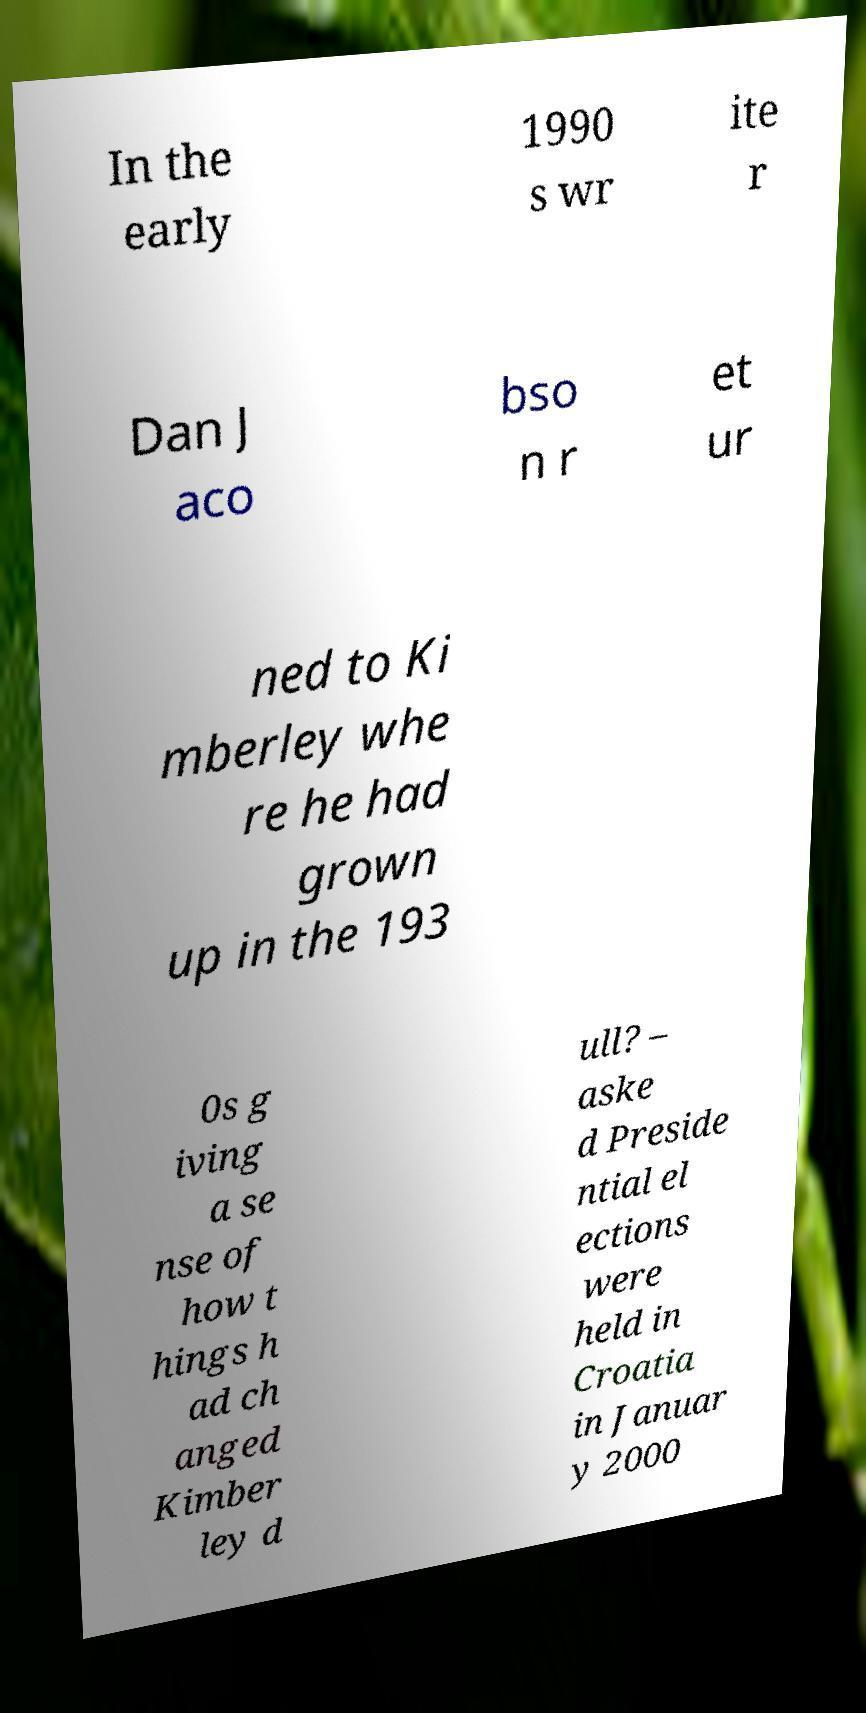Please identify and transcribe the text found in this image. In the early 1990 s wr ite r Dan J aco bso n r et ur ned to Ki mberley whe re he had grown up in the 193 0s g iving a se nse of how t hings h ad ch anged Kimber ley d ull? – aske d Preside ntial el ections were held in Croatia in Januar y 2000 